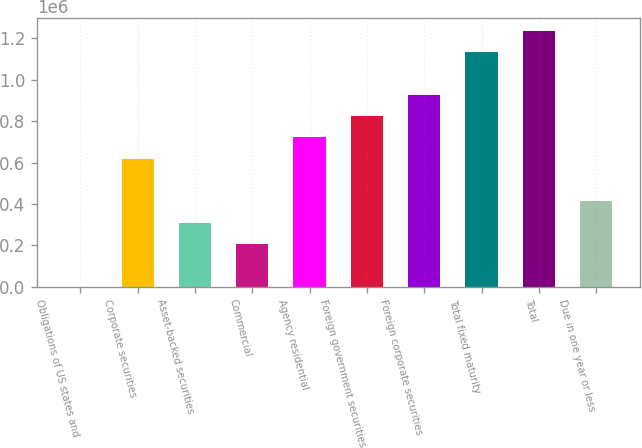<chart> <loc_0><loc_0><loc_500><loc_500><bar_chart><fcel>Obligations of US states and<fcel>Corporate securities<fcel>Asset-backed securities<fcel>Commercial<fcel>Agency residential<fcel>Foreign government securities<fcel>Foreign corporate securities<fcel>Total fixed maturity<fcel>Total<fcel>Due in one year or less<nl><fcel>564<fcel>619001<fcel>309782<fcel>206710<fcel>722074<fcel>825146<fcel>928219<fcel>1.13436e+06<fcel>1.23744e+06<fcel>412855<nl></chart> 